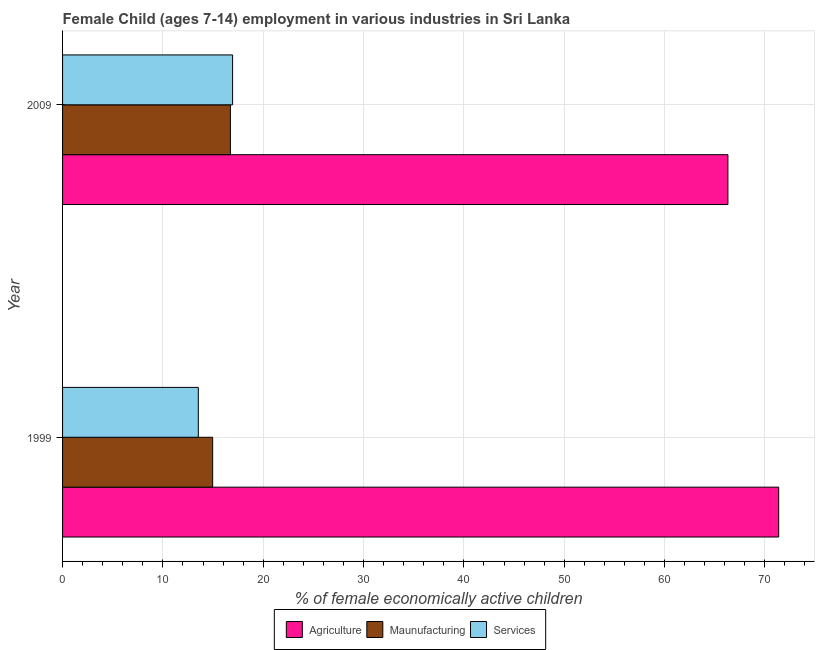How many different coloured bars are there?
Your answer should be very brief. 3. How many bars are there on the 2nd tick from the top?
Your answer should be very brief. 3. What is the label of the 1st group of bars from the top?
Make the answer very short. 2009. In how many cases, is the number of bars for a given year not equal to the number of legend labels?
Your answer should be very brief. 0. What is the percentage of economically active children in agriculture in 1999?
Your response must be concise. 71.38. Across all years, what is the maximum percentage of economically active children in manufacturing?
Give a very brief answer. 16.73. Across all years, what is the minimum percentage of economically active children in agriculture?
Your response must be concise. 66.32. What is the total percentage of economically active children in services in the graph?
Offer a terse response. 30.48. What is the difference between the percentage of economically active children in services in 1999 and that in 2009?
Offer a very short reply. -3.42. What is the difference between the percentage of economically active children in agriculture in 2009 and the percentage of economically active children in services in 1999?
Ensure brevity in your answer.  52.79. What is the average percentage of economically active children in services per year?
Keep it short and to the point. 15.24. In the year 1999, what is the difference between the percentage of economically active children in services and percentage of economically active children in agriculture?
Your response must be concise. -57.85. In how many years, is the percentage of economically active children in services greater than 72 %?
Offer a very short reply. 0. What is the ratio of the percentage of economically active children in agriculture in 1999 to that in 2009?
Keep it short and to the point. 1.08. Is the percentage of economically active children in agriculture in 1999 less than that in 2009?
Offer a terse response. No. What does the 2nd bar from the top in 2009 represents?
Give a very brief answer. Maunufacturing. What does the 3rd bar from the bottom in 1999 represents?
Provide a short and direct response. Services. Is it the case that in every year, the sum of the percentage of economically active children in agriculture and percentage of economically active children in manufacturing is greater than the percentage of economically active children in services?
Your response must be concise. Yes. Are all the bars in the graph horizontal?
Your answer should be compact. Yes. Are the values on the major ticks of X-axis written in scientific E-notation?
Keep it short and to the point. No. How many legend labels are there?
Give a very brief answer. 3. What is the title of the graph?
Offer a terse response. Female Child (ages 7-14) employment in various industries in Sri Lanka. What is the label or title of the X-axis?
Give a very brief answer. % of female economically active children. What is the label or title of the Y-axis?
Your response must be concise. Year. What is the % of female economically active children of Agriculture in 1999?
Keep it short and to the point. 71.38. What is the % of female economically active children in Maunufacturing in 1999?
Provide a succinct answer. 14.96. What is the % of female economically active children in Services in 1999?
Your response must be concise. 13.53. What is the % of female economically active children of Agriculture in 2009?
Give a very brief answer. 66.32. What is the % of female economically active children of Maunufacturing in 2009?
Provide a succinct answer. 16.73. What is the % of female economically active children in Services in 2009?
Ensure brevity in your answer.  16.95. Across all years, what is the maximum % of female economically active children of Agriculture?
Your response must be concise. 71.38. Across all years, what is the maximum % of female economically active children in Maunufacturing?
Give a very brief answer. 16.73. Across all years, what is the maximum % of female economically active children of Services?
Keep it short and to the point. 16.95. Across all years, what is the minimum % of female economically active children in Agriculture?
Offer a terse response. 66.32. Across all years, what is the minimum % of female economically active children of Maunufacturing?
Provide a succinct answer. 14.96. Across all years, what is the minimum % of female economically active children in Services?
Provide a short and direct response. 13.53. What is the total % of female economically active children of Agriculture in the graph?
Offer a very short reply. 137.7. What is the total % of female economically active children in Maunufacturing in the graph?
Your answer should be compact. 31.69. What is the total % of female economically active children in Services in the graph?
Offer a very short reply. 30.48. What is the difference between the % of female economically active children of Agriculture in 1999 and that in 2009?
Ensure brevity in your answer.  5.06. What is the difference between the % of female economically active children of Maunufacturing in 1999 and that in 2009?
Ensure brevity in your answer.  -1.77. What is the difference between the % of female economically active children in Services in 1999 and that in 2009?
Your answer should be compact. -3.42. What is the difference between the % of female economically active children of Agriculture in 1999 and the % of female economically active children of Maunufacturing in 2009?
Offer a very short reply. 54.65. What is the difference between the % of female economically active children in Agriculture in 1999 and the % of female economically active children in Services in 2009?
Keep it short and to the point. 54.43. What is the difference between the % of female economically active children of Maunufacturing in 1999 and the % of female economically active children of Services in 2009?
Your response must be concise. -1.99. What is the average % of female economically active children in Agriculture per year?
Provide a short and direct response. 68.85. What is the average % of female economically active children of Maunufacturing per year?
Keep it short and to the point. 15.85. What is the average % of female economically active children of Services per year?
Provide a succinct answer. 15.24. In the year 1999, what is the difference between the % of female economically active children in Agriculture and % of female economically active children in Maunufacturing?
Make the answer very short. 56.42. In the year 1999, what is the difference between the % of female economically active children in Agriculture and % of female economically active children in Services?
Your answer should be compact. 57.85. In the year 1999, what is the difference between the % of female economically active children in Maunufacturing and % of female economically active children in Services?
Your answer should be compact. 1.43. In the year 2009, what is the difference between the % of female economically active children in Agriculture and % of female economically active children in Maunufacturing?
Your answer should be very brief. 49.59. In the year 2009, what is the difference between the % of female economically active children of Agriculture and % of female economically active children of Services?
Provide a short and direct response. 49.37. In the year 2009, what is the difference between the % of female economically active children in Maunufacturing and % of female economically active children in Services?
Ensure brevity in your answer.  -0.22. What is the ratio of the % of female economically active children in Agriculture in 1999 to that in 2009?
Offer a very short reply. 1.08. What is the ratio of the % of female economically active children of Maunufacturing in 1999 to that in 2009?
Your answer should be very brief. 0.89. What is the ratio of the % of female economically active children of Services in 1999 to that in 2009?
Make the answer very short. 0.8. What is the difference between the highest and the second highest % of female economically active children of Agriculture?
Offer a terse response. 5.06. What is the difference between the highest and the second highest % of female economically active children in Maunufacturing?
Your answer should be compact. 1.77. What is the difference between the highest and the second highest % of female economically active children in Services?
Offer a terse response. 3.42. What is the difference between the highest and the lowest % of female economically active children in Agriculture?
Offer a terse response. 5.06. What is the difference between the highest and the lowest % of female economically active children in Maunufacturing?
Offer a terse response. 1.77. What is the difference between the highest and the lowest % of female economically active children of Services?
Provide a succinct answer. 3.42. 